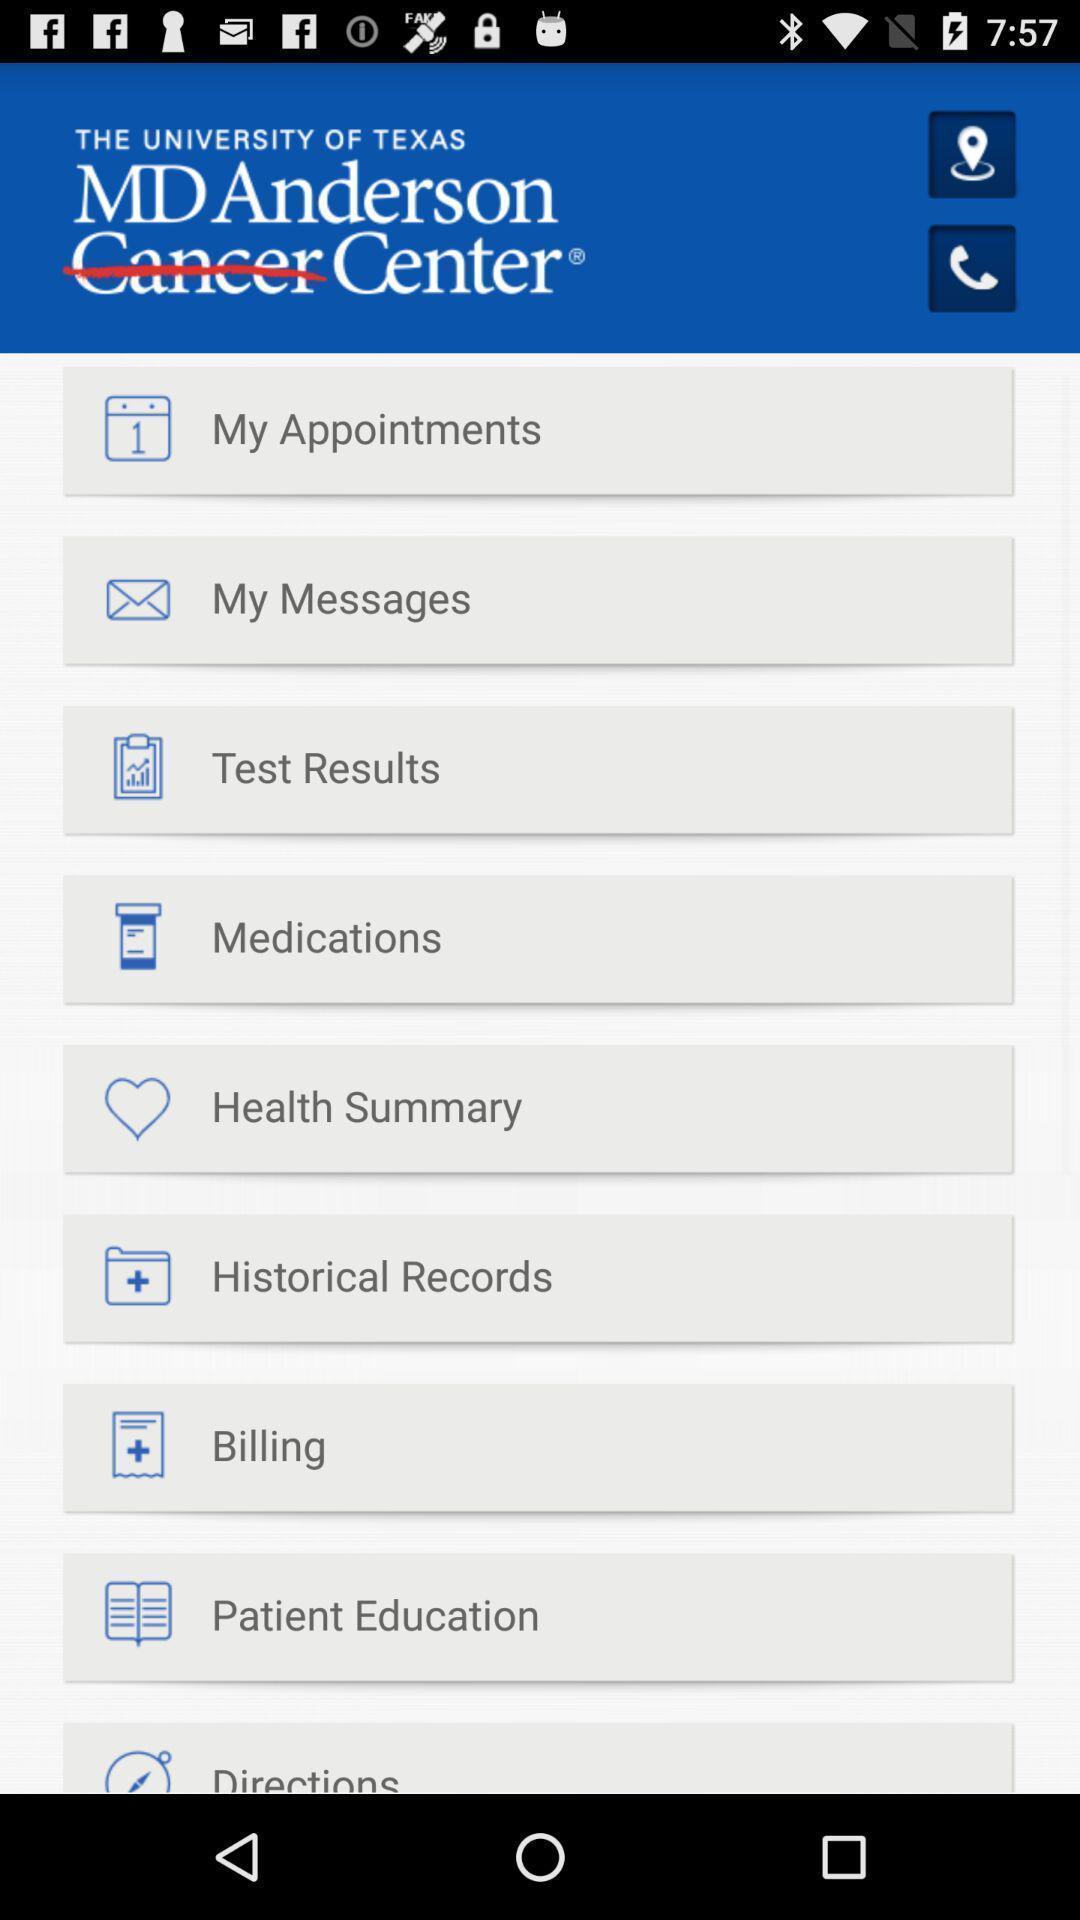Describe the visual elements of this screenshot. Page showing different options on an app. 